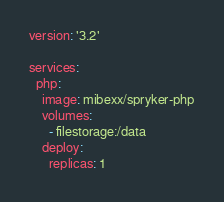Convert code to text. <code><loc_0><loc_0><loc_500><loc_500><_YAML_>version: '3.2'

services:
  php:
    image: mibexx/spryker-php
    volumes:
      - filestorage:/data
    deploy:
      replicas: 1</code> 